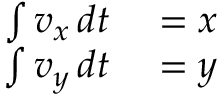<formula> <loc_0><loc_0><loc_500><loc_500>\begin{array} { r l } { \int v _ { x } \, d t } & = x } \\ { \int v _ { y } \, d t } & = y } \end{array}</formula> 